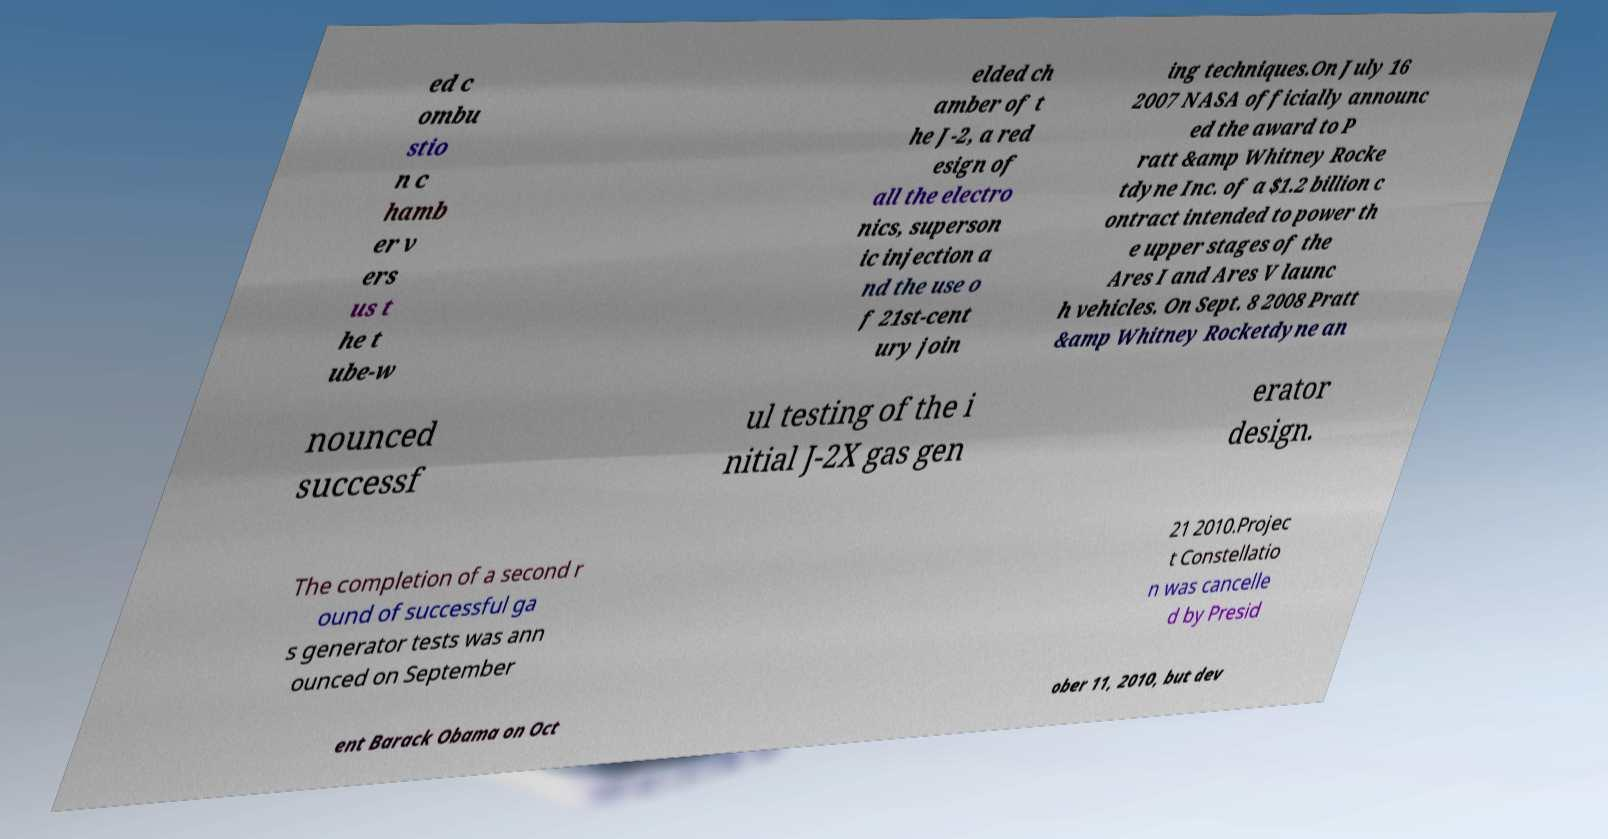Could you assist in decoding the text presented in this image and type it out clearly? ed c ombu stio n c hamb er v ers us t he t ube-w elded ch amber of t he J-2, a red esign of all the electro nics, superson ic injection a nd the use o f 21st-cent ury join ing techniques.On July 16 2007 NASA officially announc ed the award to P ratt &amp Whitney Rocke tdyne Inc. of a $1.2 billion c ontract intended to power th e upper stages of the Ares I and Ares V launc h vehicles. On Sept. 8 2008 Pratt &amp Whitney Rocketdyne an nounced successf ul testing of the i nitial J-2X gas gen erator design. The completion of a second r ound of successful ga s generator tests was ann ounced on September 21 2010.Projec t Constellatio n was cancelle d by Presid ent Barack Obama on Oct ober 11, 2010, but dev 